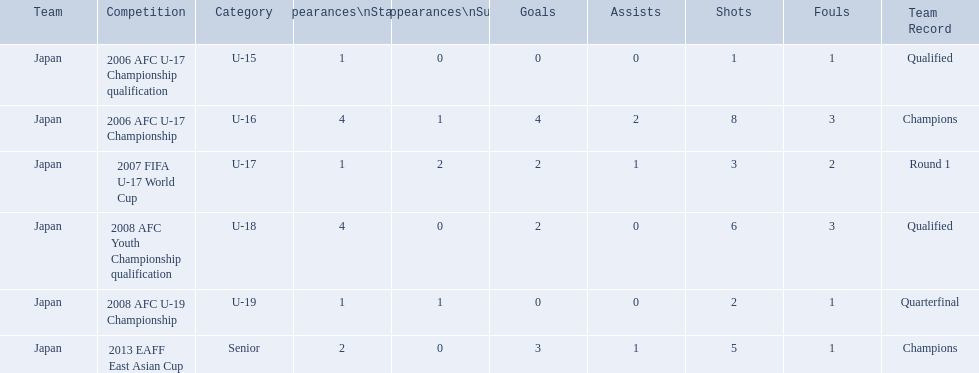Which competitions has yoichiro kakitani participated in? 2006 AFC U-17 Championship qualification, 2006 AFC U-17 Championship, 2007 FIFA U-17 World Cup, 2008 AFC Youth Championship qualification, 2008 AFC U-19 Championship, 2013 EAFF East Asian Cup. How many times did he start during each competition? 1, 4, 1, 4, 1, 2. How many goals did he score during those? 0, 4, 2, 2, 0, 3. And during which competition did yoichiro achieve the most starts and goals? 2006 AFC U-17 Championship. 